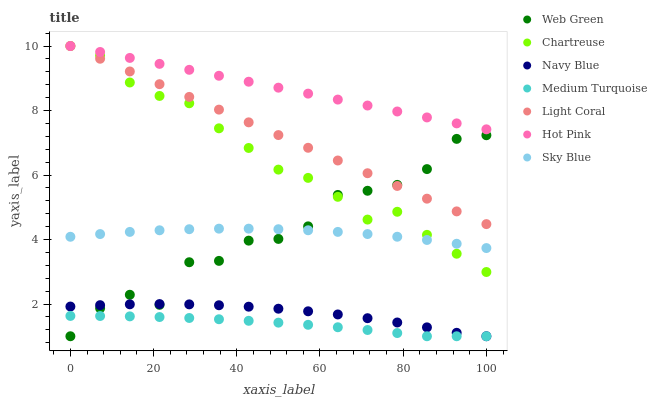Does Medium Turquoise have the minimum area under the curve?
Answer yes or no. Yes. Does Hot Pink have the maximum area under the curve?
Answer yes or no. Yes. Does Web Green have the minimum area under the curve?
Answer yes or no. No. Does Web Green have the maximum area under the curve?
Answer yes or no. No. Is Light Coral the smoothest?
Answer yes or no. Yes. Is Web Green the roughest?
Answer yes or no. Yes. Is Hot Pink the smoothest?
Answer yes or no. No. Is Hot Pink the roughest?
Answer yes or no. No. Does Navy Blue have the lowest value?
Answer yes or no. Yes. Does Hot Pink have the lowest value?
Answer yes or no. No. Does Chartreuse have the highest value?
Answer yes or no. Yes. Does Web Green have the highest value?
Answer yes or no. No. Is Navy Blue less than Chartreuse?
Answer yes or no. Yes. Is Chartreuse greater than Medium Turquoise?
Answer yes or no. Yes. Does Navy Blue intersect Web Green?
Answer yes or no. Yes. Is Navy Blue less than Web Green?
Answer yes or no. No. Is Navy Blue greater than Web Green?
Answer yes or no. No. Does Navy Blue intersect Chartreuse?
Answer yes or no. No. 